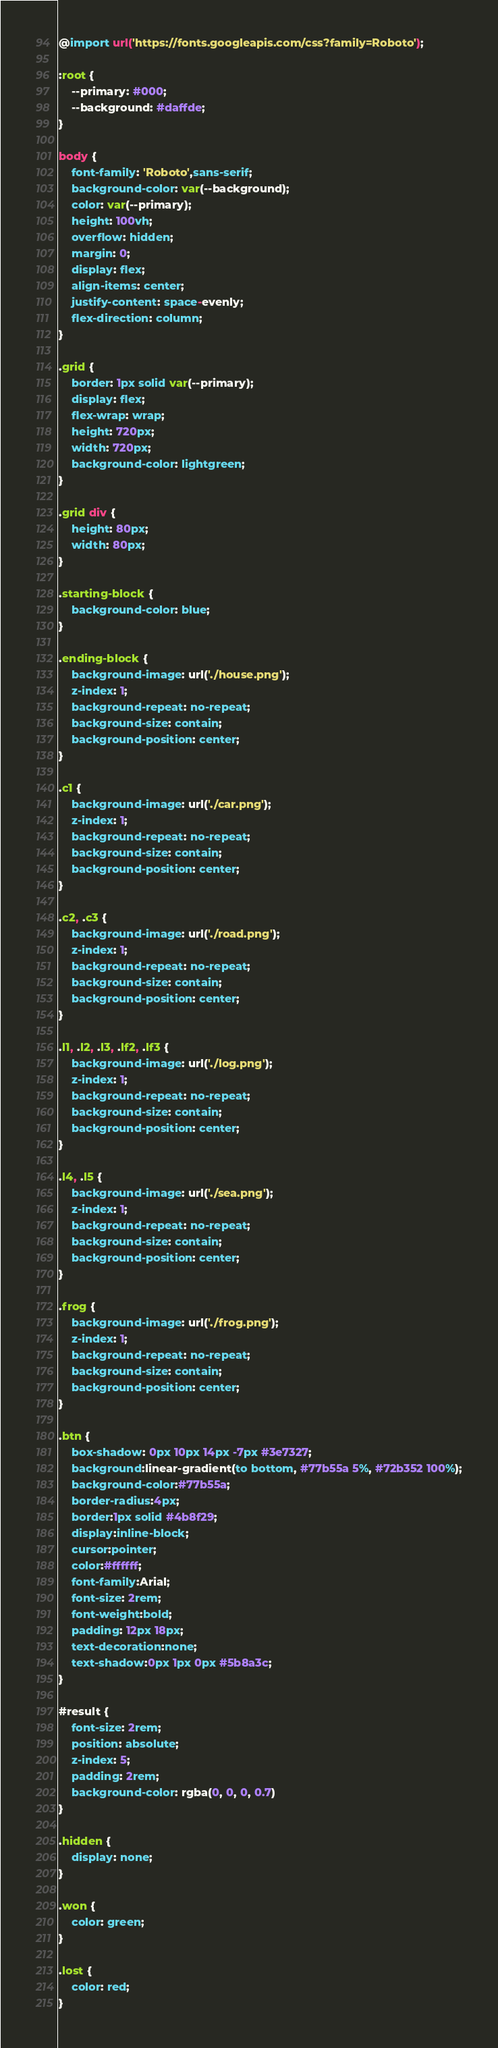Convert code to text. <code><loc_0><loc_0><loc_500><loc_500><_CSS_>@import url('https://fonts.googleapis.com/css?family=Roboto');

:root {
    --primary: #000;
    --background: #daffde;
}

body {
    font-family: 'Roboto',sans-serif;
    background-color: var(--background);
    color: var(--primary);
    height: 100vh;
    overflow: hidden;
    margin: 0;
    display: flex;
    align-items: center;
    justify-content: space-evenly;
    flex-direction: column;
}

.grid {
    border: 1px solid var(--primary);
    display: flex;
    flex-wrap: wrap;
    height: 720px;
    width: 720px;
    background-color: lightgreen;
}

.grid div {
    height: 80px;
    width: 80px;
}

.starting-block {
    background-color: blue;
}

.ending-block {
    background-image: url('./house.png');
    z-index: 1;
    background-repeat: no-repeat;
    background-size: contain;
    background-position: center;
}

.c1 {
    background-image: url('./car.png');
    z-index: 1;
    background-repeat: no-repeat;
    background-size: contain;
    background-position: center;
}

.c2, .c3 {
    background-image: url('./road.png');
    z-index: 1;
    background-repeat: no-repeat;
    background-size: contain;
    background-position: center;
}

.l1, .l2, .l3, .lf2, .lf3 {
    background-image: url('./log.png');
    z-index: 1;
    background-repeat: no-repeat;
    background-size: contain;
    background-position: center;
}

.l4, .l5 {
    background-image: url('./sea.png');
    z-index: 1;
    background-repeat: no-repeat;
    background-size: contain;
    background-position: center;
}

.frog {
    background-image: url('./frog.png');
    z-index: 1;
    background-repeat: no-repeat;
    background-size: contain;
    background-position: center;
}

.btn {
    box-shadow: 0px 10px 14px -7px #3e7327;
	background:linear-gradient(to bottom, #77b55a 5%, #72b352 100%);
	background-color:#77b55a;
	border-radius:4px;
	border:1px solid #4b8f29;
	display:inline-block;
	cursor:pointer;
	color:#ffffff;
	font-family:Arial;
	font-size: 2rem;
	font-weight:bold;
	padding: 12px 18px;
	text-decoration:none;
	text-shadow:0px 1px 0px #5b8a3c;
}

#result {
    font-size: 2rem;
    position: absolute;
    z-index: 5;
    padding: 2rem;
    background-color: rgba(0, 0, 0, 0.7)
}

.hidden {
    display: none;
}

.won {
    color: green;
}

.lost {
    color: red;
}</code> 